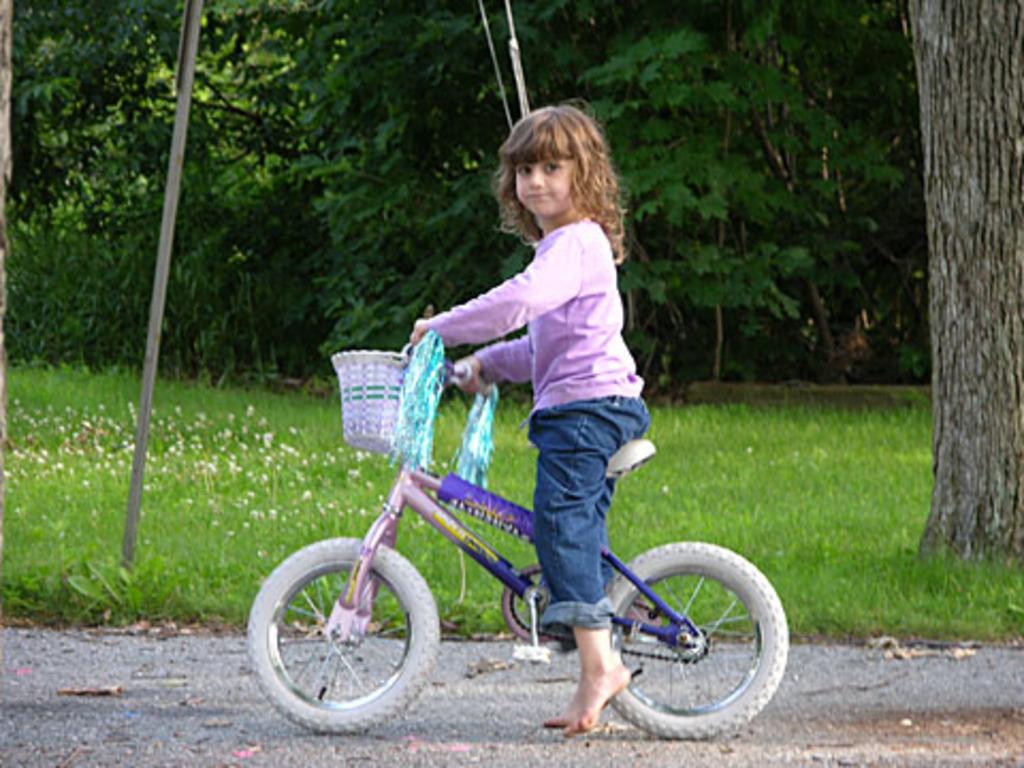Who is the main subject in the image? There is a girl in the image. What is the girl doing in the image? The girl is sitting on a bicycle. What type of natural environment is visible in the image? There are trees and grass in the image. What objects can be seen in the image that are not related to the girl or the bicycle? There are ropes and a wooden stick visible in the image. How many snakes are slithering around the girl in the image? There are no snakes present in the image. Can you see a duck swimming in the grass in the image? There is no duck visible in the image; it features a girl sitting on a bicycle in a grassy area with trees and other objects. 